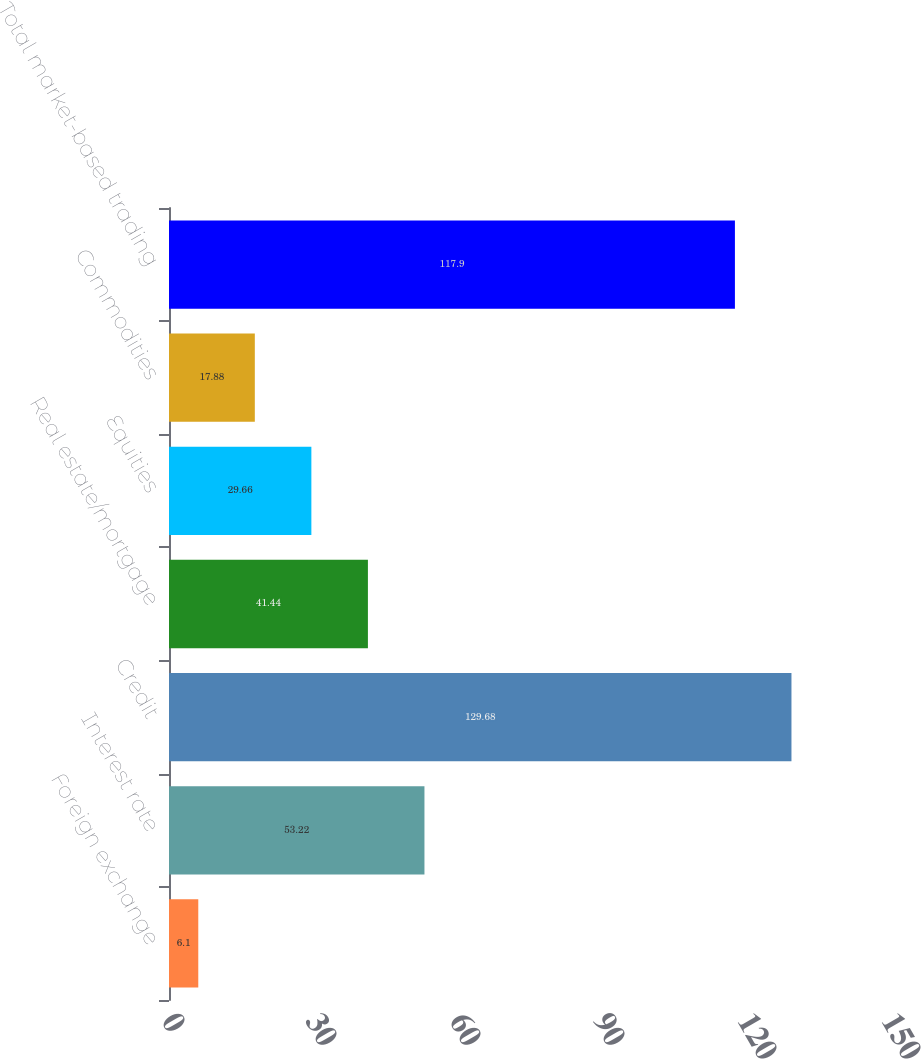Convert chart to OTSL. <chart><loc_0><loc_0><loc_500><loc_500><bar_chart><fcel>Foreign exchange<fcel>Interest rate<fcel>Credit<fcel>Real estate/mortgage<fcel>Equities<fcel>Commodities<fcel>Total market-based trading<nl><fcel>6.1<fcel>53.22<fcel>129.68<fcel>41.44<fcel>29.66<fcel>17.88<fcel>117.9<nl></chart> 